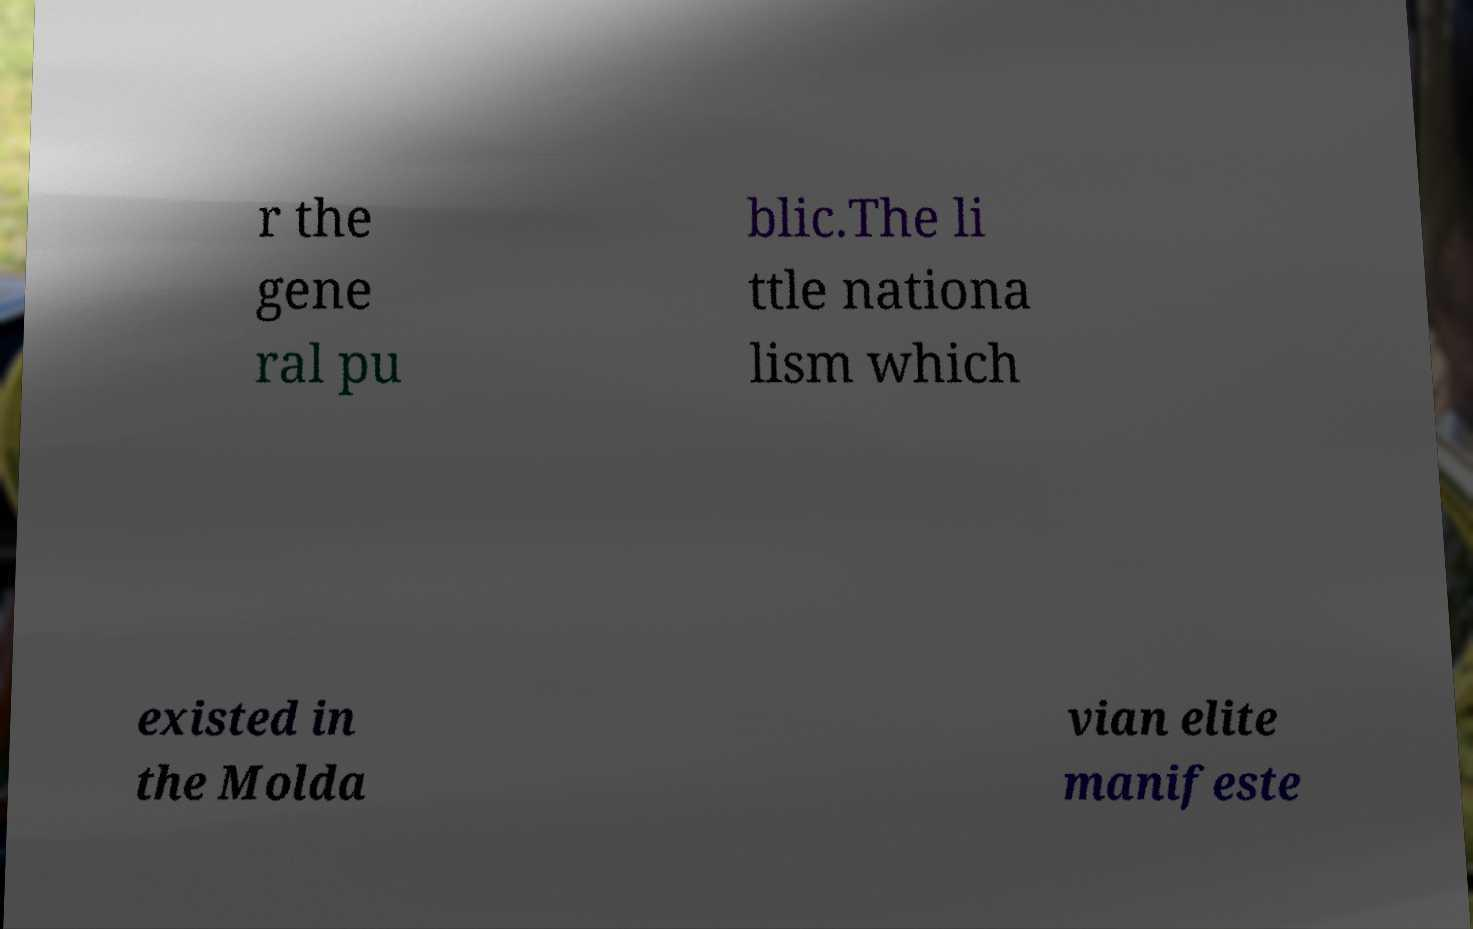Please read and relay the text visible in this image. What does it say? r the gene ral pu blic.The li ttle nationa lism which existed in the Molda vian elite manifeste 